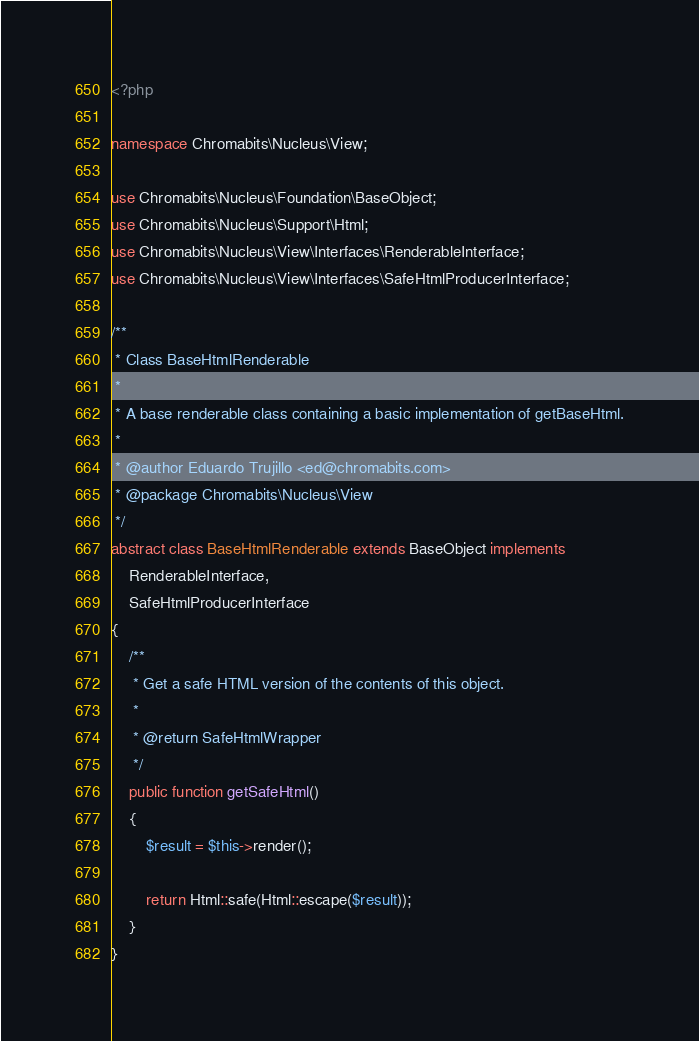<code> <loc_0><loc_0><loc_500><loc_500><_PHP_><?php

namespace Chromabits\Nucleus\View;

use Chromabits\Nucleus\Foundation\BaseObject;
use Chromabits\Nucleus\Support\Html;
use Chromabits\Nucleus\View\Interfaces\RenderableInterface;
use Chromabits\Nucleus\View\Interfaces\SafeHtmlProducerInterface;

/**
 * Class BaseHtmlRenderable
 *
 * A base renderable class containing a basic implementation of getBaseHtml.
 *
 * @author Eduardo Trujillo <ed@chromabits.com>
 * @package Chromabits\Nucleus\View
 */
abstract class BaseHtmlRenderable extends BaseObject implements
    RenderableInterface,
    SafeHtmlProducerInterface
{
    /**
     * Get a safe HTML version of the contents of this object.
     *
     * @return SafeHtmlWrapper
     */
    public function getSafeHtml()
    {
        $result = $this->render();

        return Html::safe(Html::escape($result));
    }
}
</code> 